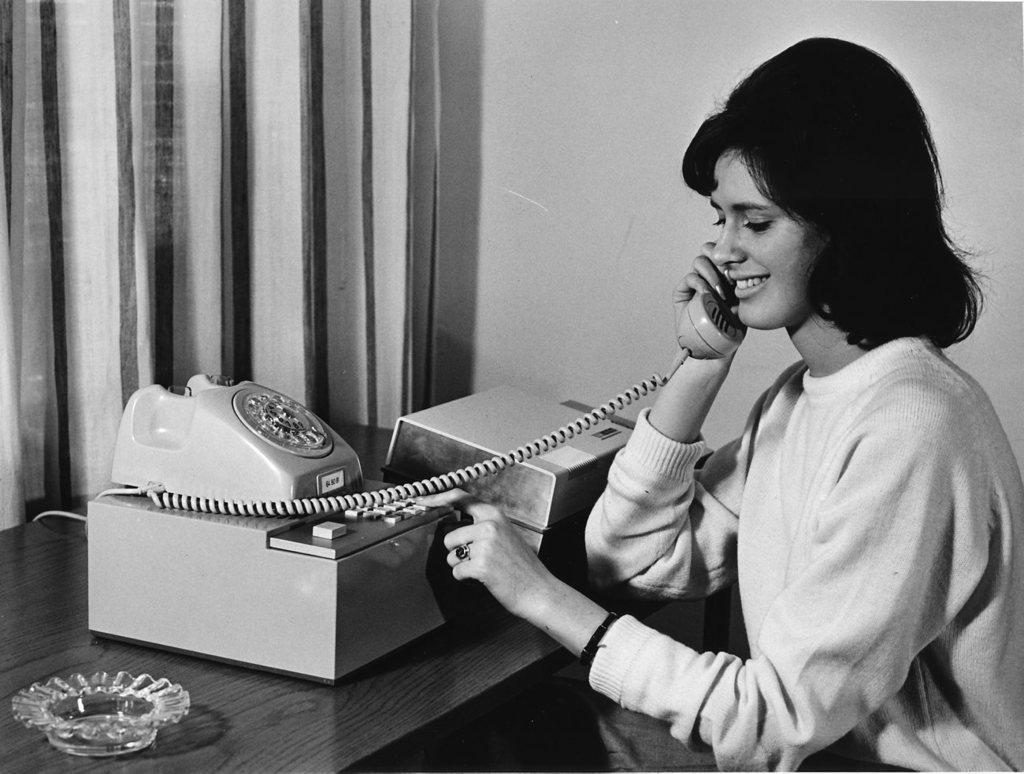Please provide a concise description of this image. In this picture there is a old photograph of the woman, sitting on a chair and talking on the phone. In the front we can see the table with telephone and ashtray. Behind there is a curtain and wall. 